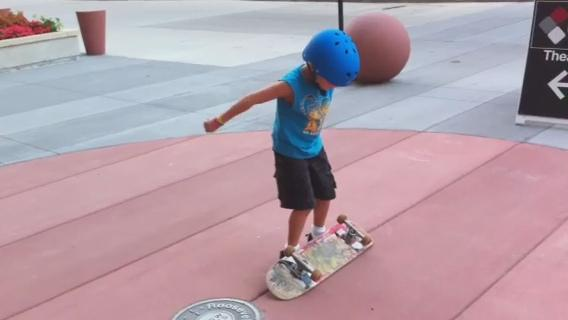What will the child try to do first? Please explain your reasoning. flip board. He will try to flip his board around. 